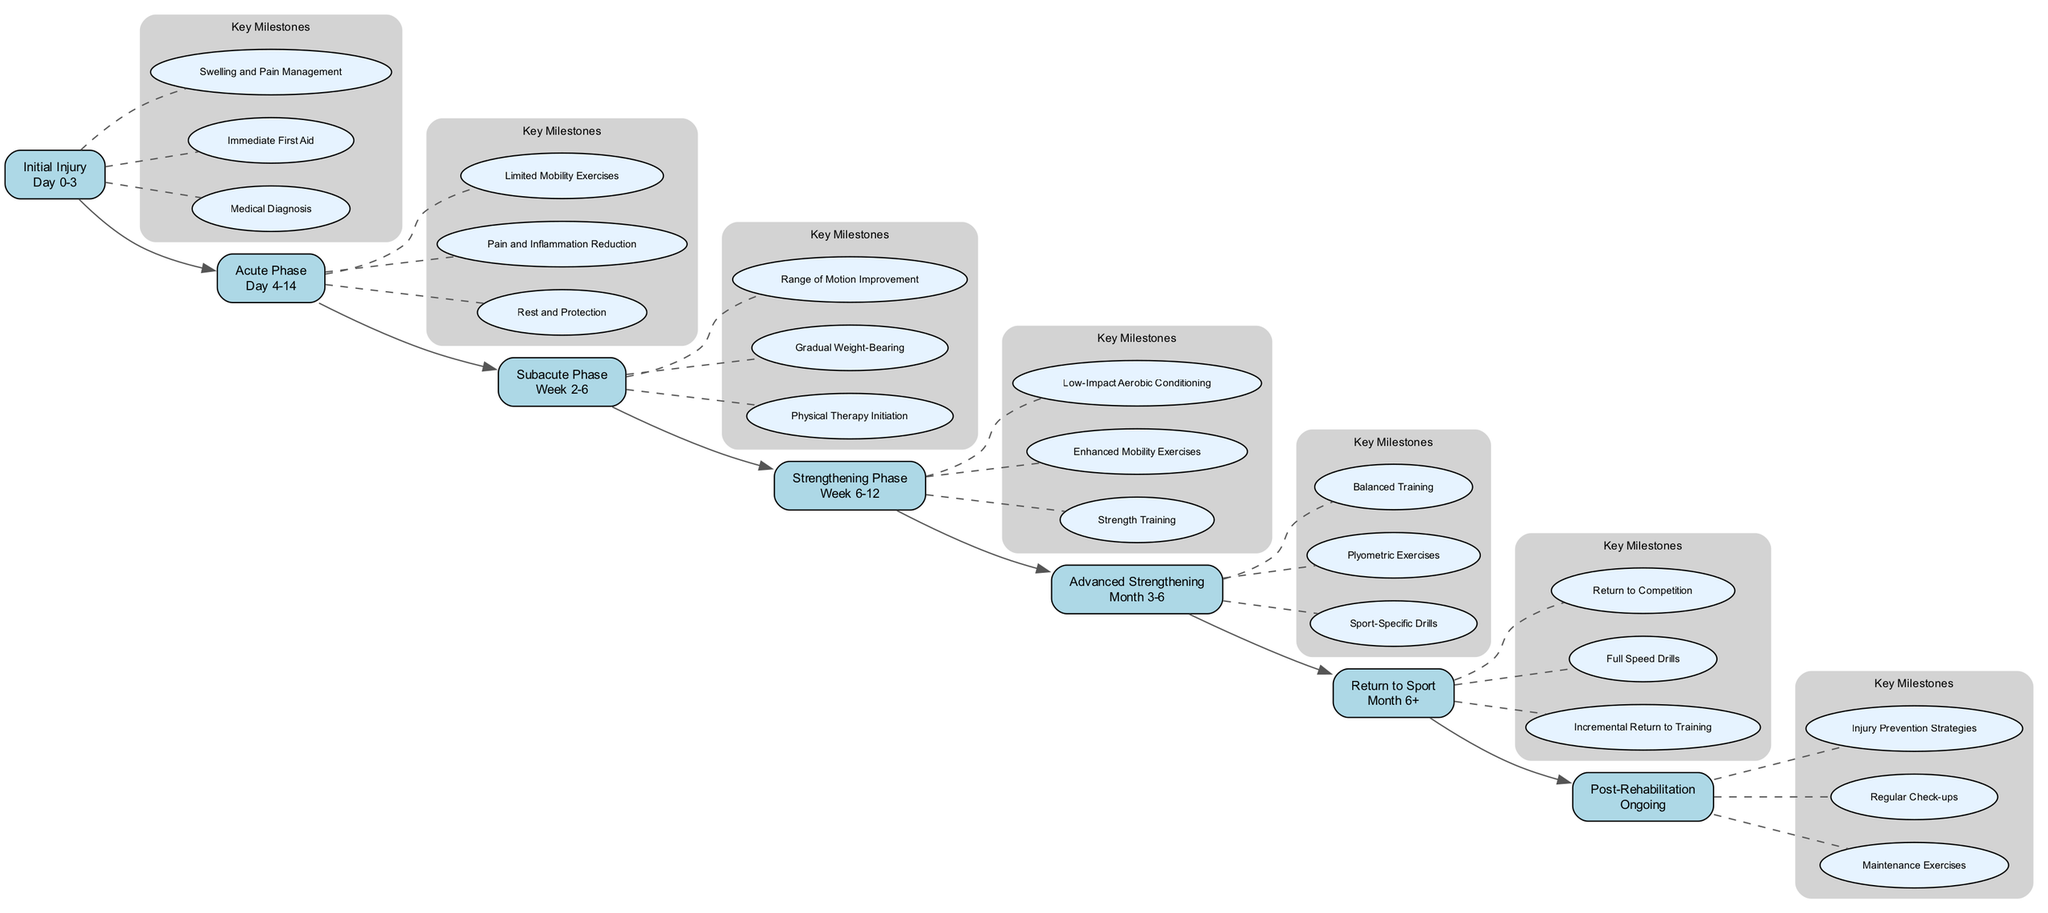What is the timeline for the Acute Phase? The diagram shows that the Acute Phase spans from Day 4 to Day 14.
Answer: Day 4-14 How many key milestones are listed for the Strengthening Phase? The Strengthening Phase has three key milestones: Strength Training, Enhanced Mobility Exercises, Low-Impact Aerobic Conditioning.
Answer: 3 What is the first key milestone in the Initial Injury phase? The first key milestone listed for the Initial Injury phase is Medical Diagnosis.
Answer: Medical Diagnosis Which phase follows the Subacute Phase? The diagram indicates that the Strengthening Phase follows the Subacute Phase.
Answer: Strengthening Phase What type of exercises are introduced in the Advanced Strengthening phase? The Advanced Strengthening phase focuses on Sport-Specific Drills.
Answer: Sport-Specific Drills How long does the Return to Sport phase last? The diagram states that the Return to Sport phase lasts for Month 6 and beyond.
Answer: Month 6+ What key milestone is related to the Post-Rehabilitation phase? The key milestone listed under the Post-Rehabilitation phase is Maintenance Exercises.
Answer: Maintenance Exercises How are the key milestones connected to the phases? The key milestones are connected to each phase with dashed lines, indicating that they are specific to that phase.
Answer: Dashed lines What is the last milestone in the rehabilitation timeline? The last milestone illustrated in the diagram is Injury Prevention Strategies in the Post-Rehabilitation phase.
Answer: Injury Prevention Strategies 